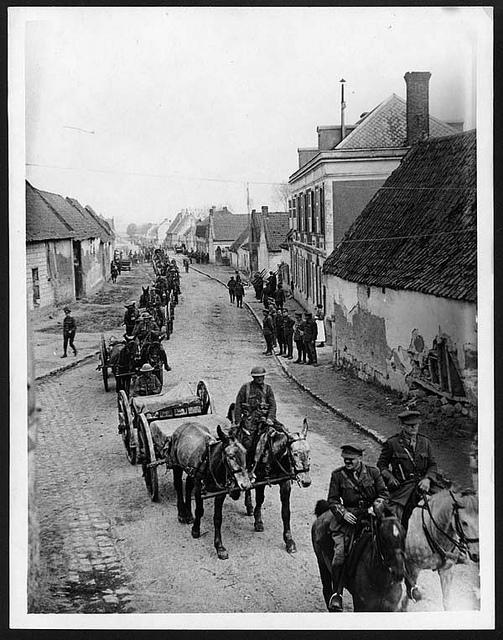How many horses are  in the foreground?
Give a very brief answer. 4. Is this a recent photo?
Concise answer only. No. Why is this picture in black and white?
Answer briefly. Old. 